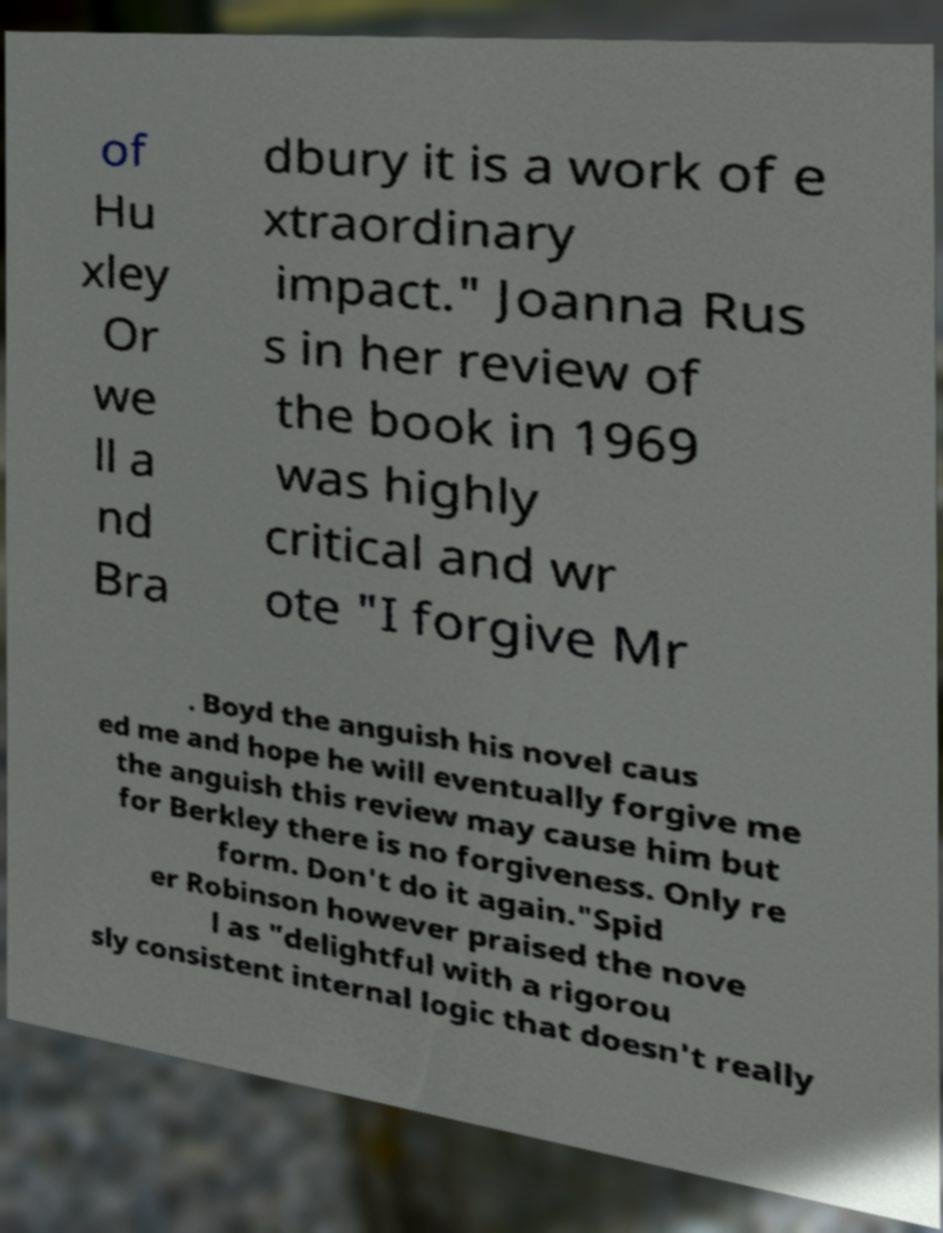Please read and relay the text visible in this image. What does it say? of Hu xley Or we ll a nd Bra dbury it is a work of e xtraordinary impact." Joanna Rus s in her review of the book in 1969 was highly critical and wr ote "I forgive Mr . Boyd the anguish his novel caus ed me and hope he will eventually forgive me the anguish this review may cause him but for Berkley there is no forgiveness. Only re form. Don't do it again."Spid er Robinson however praised the nove l as "delightful with a rigorou sly consistent internal logic that doesn't really 